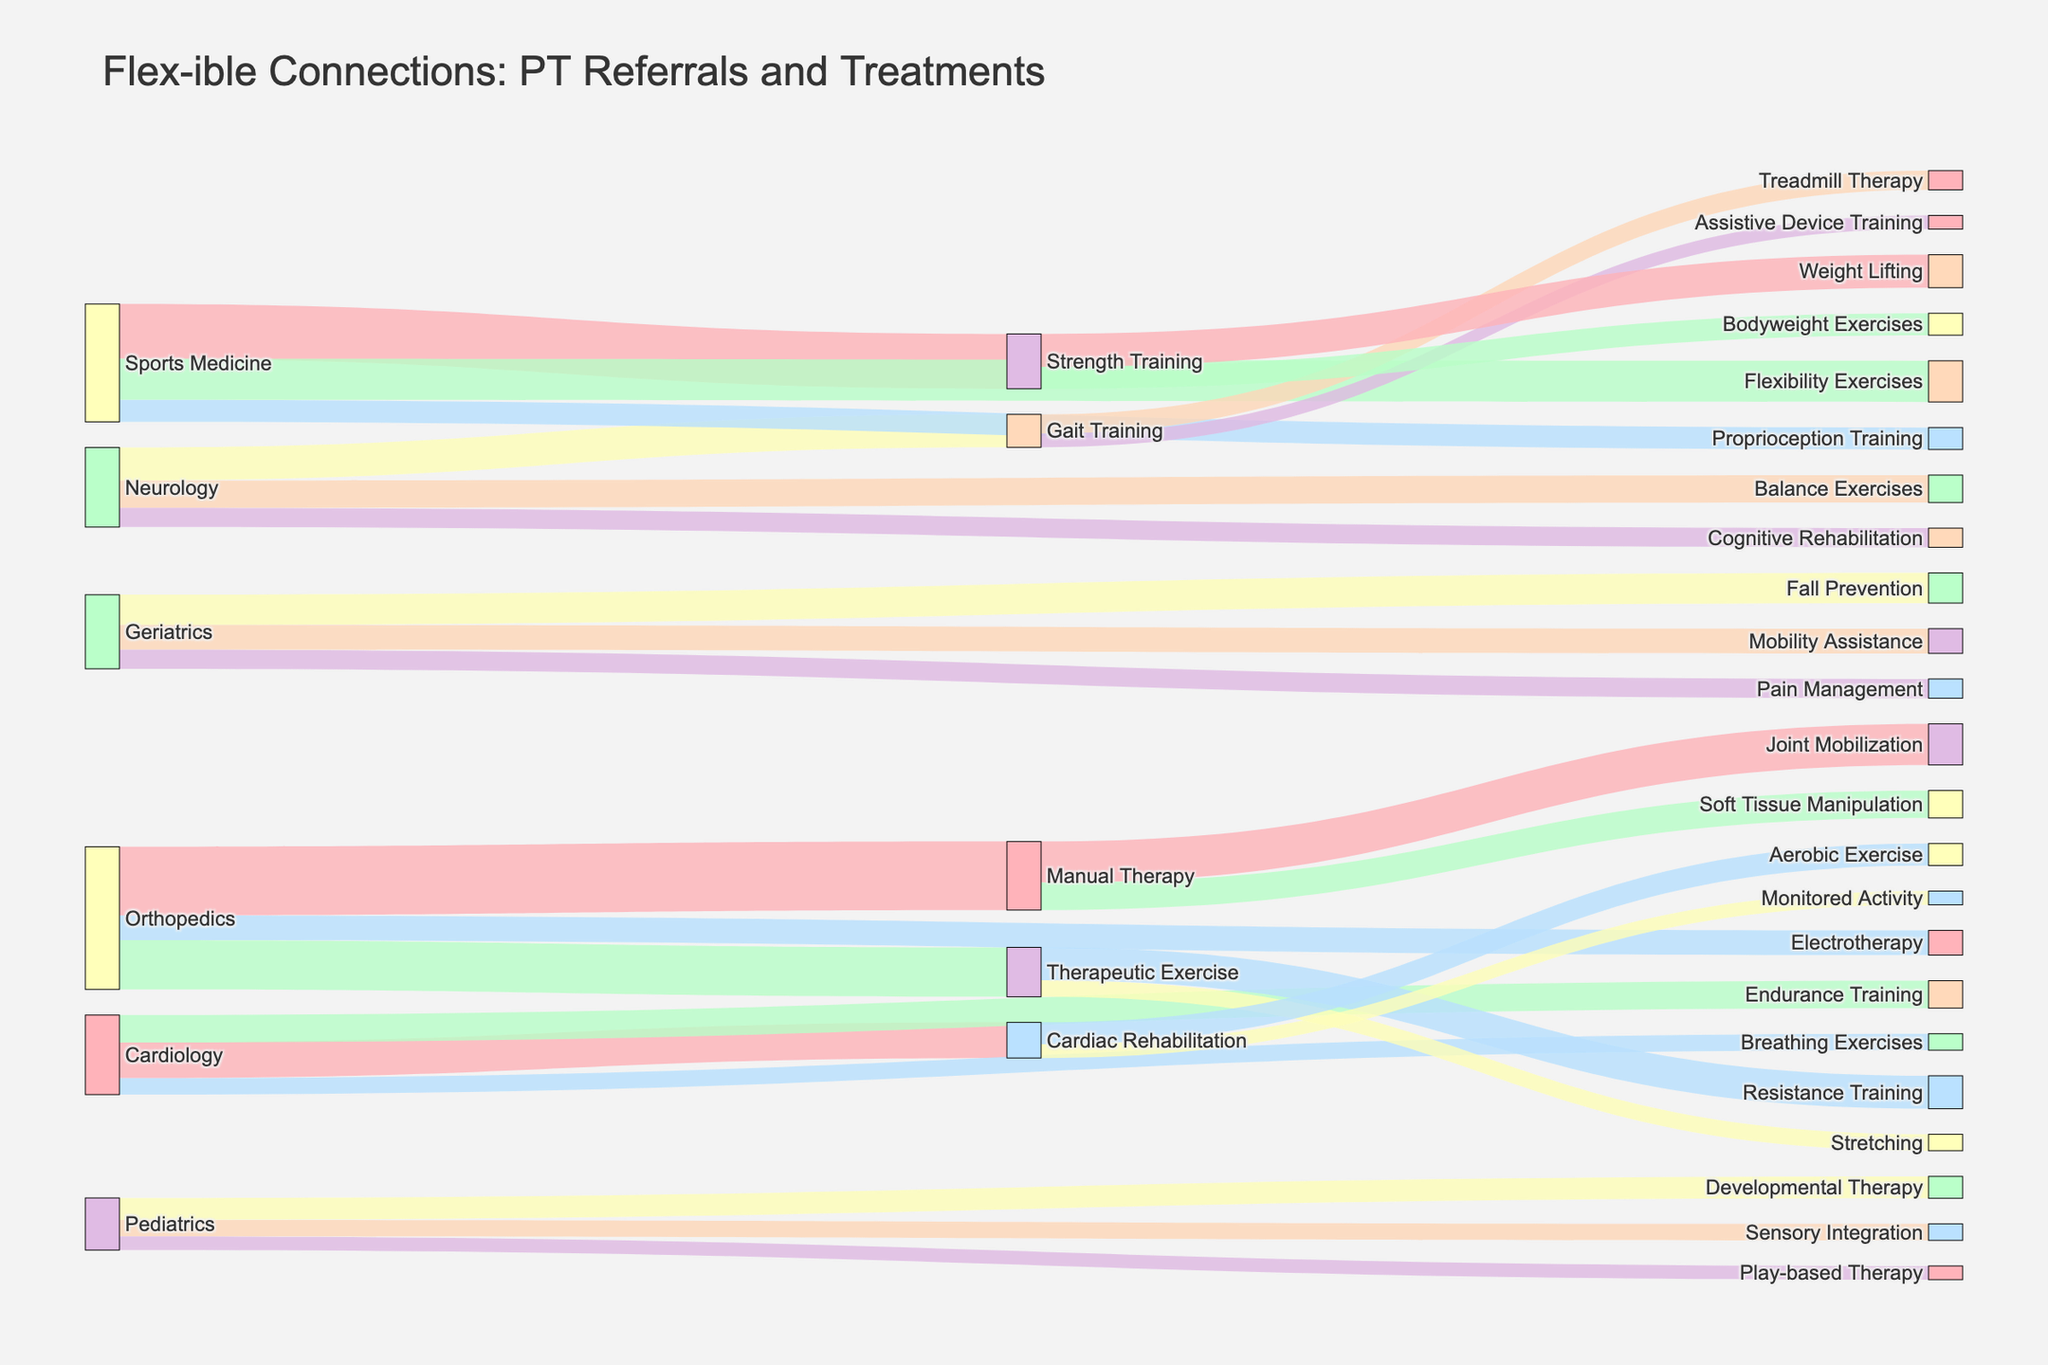What's the title of the figure? The title of the figure is clearly displayed at the top, which helps the viewer understand what the diagram represents.
Answer: Flex-ible Connections: PT Referrals and Treatments Which medical specialty refers the most patients to Manual Therapy? By looking at the length and thickness of the flow lines from various specialties to Manual Therapy, you can identify the specialty with the largest flow.
Answer: Orthopedics How many total referrals does Geriatrics provide? To find the total referrals provided by Geriatrics, sum the values of all the flow lines originating from Geriatrics. That includes Fall Prevention (110), Mobility Assistance (90), and Pain Management (70).
Answer: 270 Does Sports Medicine refer more patients to Strength Training or Flexibility Exercises? Compare the lengths and thickness of the flow lines from Sports Medicine to Strength Training and to Flexibility Exercises. Strength Training is 200 and Flexibility Exercises is 150.
Answer: Strength Training Which specific treatment type within Manual Therapy receives the most referrals? From the target nodes under Manual Therapy, compare the lengths and values leading to Joint Mobilization and Soft Tissue Manipulation. Joint Mobilization receives 150 referrals whereas Soft Tissue Manipulation receives 100.
Answer: Joint Mobilization What's the least common referral type from Cardiology? Compare the values of the flow lines originating from Cardiology to identify the smallest number. Cardiac Rehabilitation (130), Endurance Training (100), and Breathing Exercises (60). Breathing Exercises is the smallest.
Answer: Breathing Exercises How many different types of treatment are referred to from Orthopedics? Count the number of unique target nodes that flow from the Orthopedics source node.
Answer: 3 Between Neurology and Pediatrics, which has a greater total number of referrals? Sum the values of all flow lines from Neurology and compare with the sum for Pediatrics. Neurology: Gait Training (120), Balance Exercises (100), Cognitive Rehabilitation (70). Total: 290. Pediatrics: Developmental Therapy (80), Sensory Integration (60), Play-based Therapy (50). Total: 190.
Answer: Neurology What is the combined number of referrals from Orthopedics and Sports Medicine to their respective strength-based treatments? Identify the strength-related treatments from Orthopedics (Therapeutic Exercise with 180) and Sports Medicine (Strength Training with 200) and add them up.
Answer: 380 Which therapy type has connections to the most specific sub-treatments? Count the number of unique target nodes that connect from each major therapy type to their sub-treatments and identify the highest count. Manual Therapy has Joint Mobilization (150), Soft Tissue Manipulation (100), making 2 sub-treatments. Therapeutic Exercise has Resistance Training (120), Stretching (60), making 2 sub-treatments. Gait Training has Treadmill Therapy (70), Assistive Device Training (50), making 2 sub-treatments. Strength Training has Weight Lifting (120), Bodyweight Exercises (80), making 2 sub-treatments. Cardiac Rehabilitation has Aerobic Exercise (80), Monitored Activity (50), making 2 sub-treatments. They all tie.
Answer: Manual Therapy, Therapeutic Exercise, Gait Training, Strength Training, Cardiac Rehabilitation 